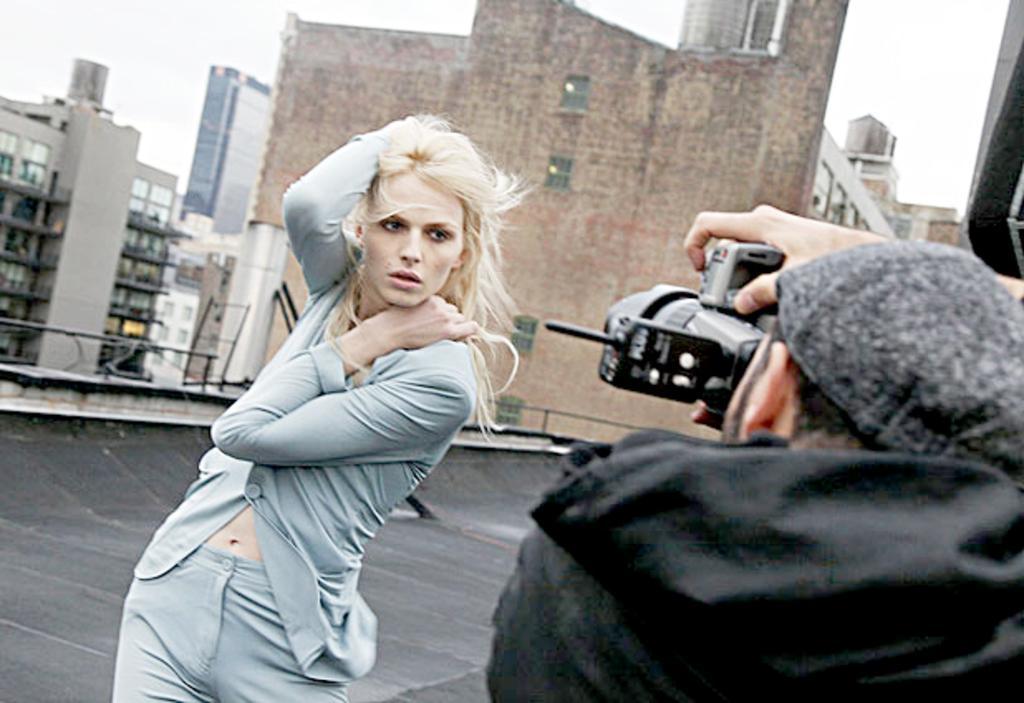How would you summarize this image in a sentence or two? In this image there is a man taking photo of a woman, in the background there are buildings. 